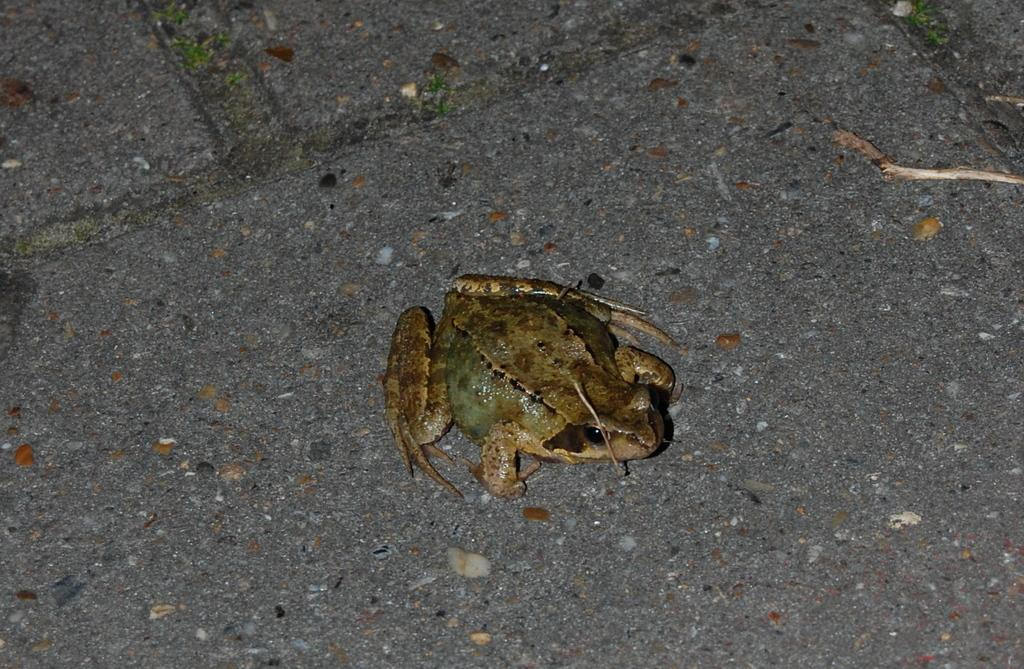What type of animal is in the image? There is a frog in the image. Where is the frog located in the image? The frog is on the floor. How does the frog compare to a ladybug in terms of size in the image? There is no ladybug present in the image, so it is not possible to make a comparison. 